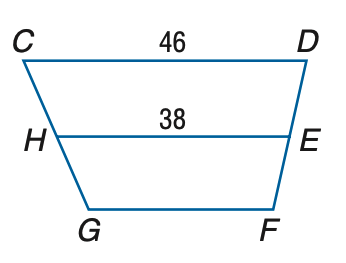Answer the mathemtical geometry problem and directly provide the correct option letter.
Question: Refer to trapezoid C D F G with median H E. Let W X be the median of C D E H. Find W X.
Choices: A: 34 B: 38 C: 42 D: 46 C 